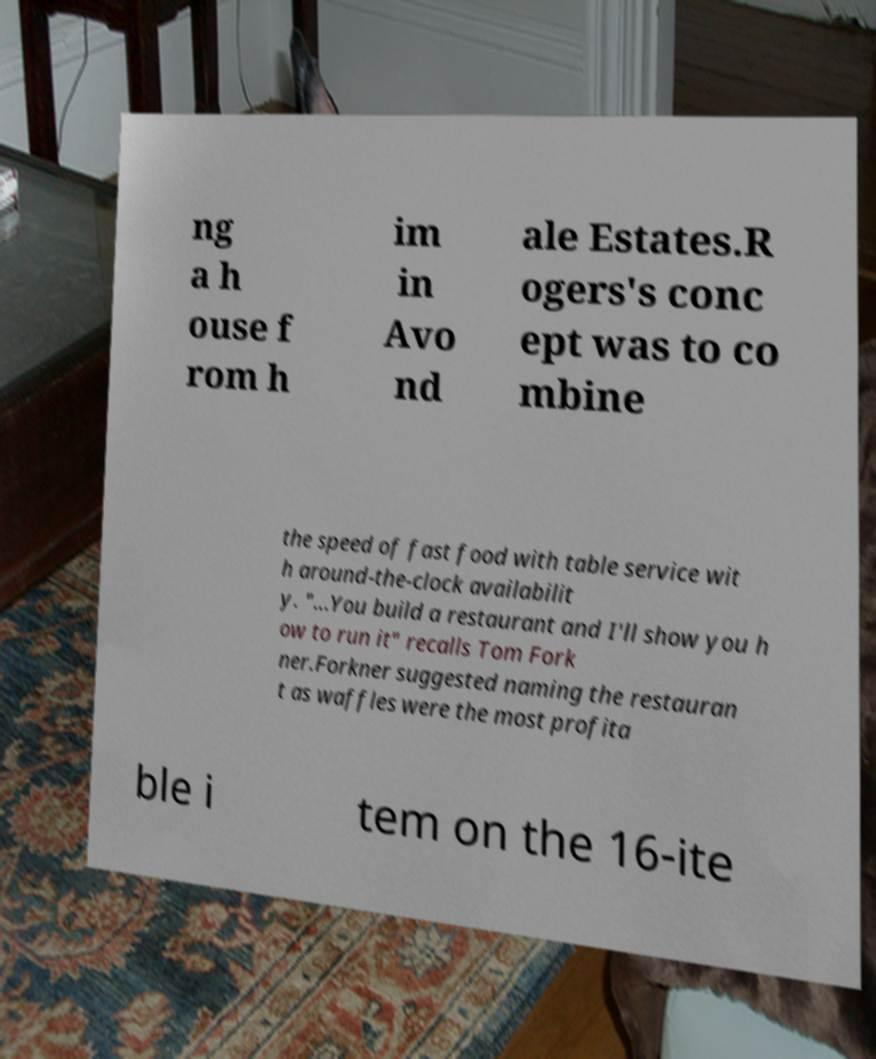Could you extract and type out the text from this image? ng a h ouse f rom h im in Avo nd ale Estates.R ogers's conc ept was to co mbine the speed of fast food with table service wit h around-the-clock availabilit y. "...You build a restaurant and I'll show you h ow to run it" recalls Tom Fork ner.Forkner suggested naming the restauran t as waffles were the most profita ble i tem on the 16-ite 